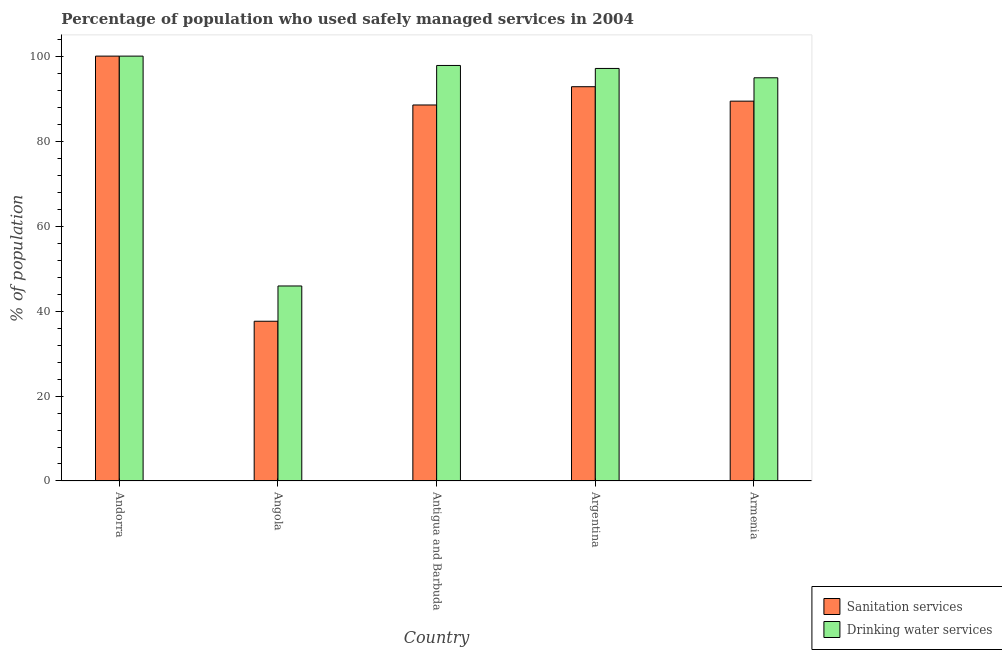How many different coloured bars are there?
Your response must be concise. 2. Are the number of bars per tick equal to the number of legend labels?
Ensure brevity in your answer.  Yes. How many bars are there on the 3rd tick from the right?
Ensure brevity in your answer.  2. What is the label of the 2nd group of bars from the left?
Offer a terse response. Angola. In how many cases, is the number of bars for a given country not equal to the number of legend labels?
Your response must be concise. 0. What is the percentage of population who used sanitation services in Antigua and Barbuda?
Make the answer very short. 88.5. Across all countries, what is the maximum percentage of population who used sanitation services?
Your response must be concise. 100. Across all countries, what is the minimum percentage of population who used drinking water services?
Your response must be concise. 45.9. In which country was the percentage of population who used sanitation services maximum?
Offer a very short reply. Andorra. In which country was the percentage of population who used drinking water services minimum?
Your answer should be very brief. Angola. What is the total percentage of population who used drinking water services in the graph?
Give a very brief answer. 435.7. What is the difference between the percentage of population who used drinking water services in Andorra and that in Angola?
Make the answer very short. 54.1. What is the difference between the percentage of population who used drinking water services in Angola and the percentage of population who used sanitation services in Argentina?
Make the answer very short. -46.9. What is the average percentage of population who used sanitation services per country?
Give a very brief answer. 81.66. What is the difference between the percentage of population who used drinking water services and percentage of population who used sanitation services in Angola?
Your response must be concise. 8.3. In how many countries, is the percentage of population who used sanitation services greater than 96 %?
Your answer should be compact. 1. What is the ratio of the percentage of population who used sanitation services in Antigua and Barbuda to that in Argentina?
Keep it short and to the point. 0.95. What is the difference between the highest and the second highest percentage of population who used drinking water services?
Ensure brevity in your answer.  2.2. What is the difference between the highest and the lowest percentage of population who used sanitation services?
Offer a terse response. 62.4. In how many countries, is the percentage of population who used drinking water services greater than the average percentage of population who used drinking water services taken over all countries?
Provide a short and direct response. 4. What does the 2nd bar from the left in Antigua and Barbuda represents?
Keep it short and to the point. Drinking water services. What does the 2nd bar from the right in Argentina represents?
Give a very brief answer. Sanitation services. Are all the bars in the graph horizontal?
Your answer should be very brief. No. Where does the legend appear in the graph?
Your answer should be compact. Bottom right. How many legend labels are there?
Keep it short and to the point. 2. What is the title of the graph?
Offer a terse response. Percentage of population who used safely managed services in 2004. Does "Personal remittances" appear as one of the legend labels in the graph?
Offer a terse response. No. What is the label or title of the Y-axis?
Give a very brief answer. % of population. What is the % of population of Sanitation services in Angola?
Your answer should be compact. 37.6. What is the % of population in Drinking water services in Angola?
Your response must be concise. 45.9. What is the % of population of Sanitation services in Antigua and Barbuda?
Your answer should be compact. 88.5. What is the % of population in Drinking water services in Antigua and Barbuda?
Ensure brevity in your answer.  97.8. What is the % of population of Sanitation services in Argentina?
Provide a short and direct response. 92.8. What is the % of population in Drinking water services in Argentina?
Your answer should be compact. 97.1. What is the % of population in Sanitation services in Armenia?
Provide a succinct answer. 89.4. What is the % of population of Drinking water services in Armenia?
Offer a terse response. 94.9. Across all countries, what is the minimum % of population in Sanitation services?
Provide a short and direct response. 37.6. Across all countries, what is the minimum % of population of Drinking water services?
Give a very brief answer. 45.9. What is the total % of population in Sanitation services in the graph?
Give a very brief answer. 408.3. What is the total % of population of Drinking water services in the graph?
Offer a terse response. 435.7. What is the difference between the % of population of Sanitation services in Andorra and that in Angola?
Ensure brevity in your answer.  62.4. What is the difference between the % of population in Drinking water services in Andorra and that in Angola?
Provide a short and direct response. 54.1. What is the difference between the % of population of Drinking water services in Andorra and that in Antigua and Barbuda?
Ensure brevity in your answer.  2.2. What is the difference between the % of population in Sanitation services in Andorra and that in Argentina?
Make the answer very short. 7.2. What is the difference between the % of population of Drinking water services in Andorra and that in Argentina?
Give a very brief answer. 2.9. What is the difference between the % of population in Sanitation services in Angola and that in Antigua and Barbuda?
Provide a short and direct response. -50.9. What is the difference between the % of population in Drinking water services in Angola and that in Antigua and Barbuda?
Your answer should be compact. -51.9. What is the difference between the % of population in Sanitation services in Angola and that in Argentina?
Your response must be concise. -55.2. What is the difference between the % of population in Drinking water services in Angola and that in Argentina?
Keep it short and to the point. -51.2. What is the difference between the % of population of Sanitation services in Angola and that in Armenia?
Offer a terse response. -51.8. What is the difference between the % of population in Drinking water services in Angola and that in Armenia?
Offer a terse response. -49. What is the difference between the % of population of Sanitation services in Antigua and Barbuda and that in Armenia?
Offer a very short reply. -0.9. What is the difference between the % of population of Sanitation services in Andorra and the % of population of Drinking water services in Angola?
Provide a short and direct response. 54.1. What is the difference between the % of population in Sanitation services in Angola and the % of population in Drinking water services in Antigua and Barbuda?
Your response must be concise. -60.2. What is the difference between the % of population of Sanitation services in Angola and the % of population of Drinking water services in Argentina?
Provide a succinct answer. -59.5. What is the difference between the % of population of Sanitation services in Angola and the % of population of Drinking water services in Armenia?
Keep it short and to the point. -57.3. What is the difference between the % of population in Sanitation services in Antigua and Barbuda and the % of population in Drinking water services in Argentina?
Your answer should be very brief. -8.6. What is the difference between the % of population of Sanitation services in Antigua and Barbuda and the % of population of Drinking water services in Armenia?
Offer a very short reply. -6.4. What is the difference between the % of population in Sanitation services in Argentina and the % of population in Drinking water services in Armenia?
Your response must be concise. -2.1. What is the average % of population of Sanitation services per country?
Give a very brief answer. 81.66. What is the average % of population in Drinking water services per country?
Provide a short and direct response. 87.14. What is the difference between the % of population of Sanitation services and % of population of Drinking water services in Andorra?
Keep it short and to the point. 0. What is the ratio of the % of population in Sanitation services in Andorra to that in Angola?
Provide a short and direct response. 2.66. What is the ratio of the % of population of Drinking water services in Andorra to that in Angola?
Provide a succinct answer. 2.18. What is the ratio of the % of population in Sanitation services in Andorra to that in Antigua and Barbuda?
Offer a very short reply. 1.13. What is the ratio of the % of population of Drinking water services in Andorra to that in Antigua and Barbuda?
Offer a very short reply. 1.02. What is the ratio of the % of population in Sanitation services in Andorra to that in Argentina?
Your answer should be compact. 1.08. What is the ratio of the % of population in Drinking water services in Andorra to that in Argentina?
Your answer should be compact. 1.03. What is the ratio of the % of population of Sanitation services in Andorra to that in Armenia?
Offer a very short reply. 1.12. What is the ratio of the % of population of Drinking water services in Andorra to that in Armenia?
Make the answer very short. 1.05. What is the ratio of the % of population of Sanitation services in Angola to that in Antigua and Barbuda?
Keep it short and to the point. 0.42. What is the ratio of the % of population of Drinking water services in Angola to that in Antigua and Barbuda?
Ensure brevity in your answer.  0.47. What is the ratio of the % of population of Sanitation services in Angola to that in Argentina?
Keep it short and to the point. 0.41. What is the ratio of the % of population in Drinking water services in Angola to that in Argentina?
Offer a very short reply. 0.47. What is the ratio of the % of population of Sanitation services in Angola to that in Armenia?
Ensure brevity in your answer.  0.42. What is the ratio of the % of population in Drinking water services in Angola to that in Armenia?
Offer a very short reply. 0.48. What is the ratio of the % of population in Sanitation services in Antigua and Barbuda to that in Argentina?
Give a very brief answer. 0.95. What is the ratio of the % of population in Drinking water services in Antigua and Barbuda to that in Argentina?
Provide a short and direct response. 1.01. What is the ratio of the % of population in Drinking water services in Antigua and Barbuda to that in Armenia?
Keep it short and to the point. 1.03. What is the ratio of the % of population of Sanitation services in Argentina to that in Armenia?
Offer a terse response. 1.04. What is the ratio of the % of population of Drinking water services in Argentina to that in Armenia?
Your response must be concise. 1.02. What is the difference between the highest and the second highest % of population of Sanitation services?
Make the answer very short. 7.2. What is the difference between the highest and the lowest % of population in Sanitation services?
Keep it short and to the point. 62.4. What is the difference between the highest and the lowest % of population in Drinking water services?
Ensure brevity in your answer.  54.1. 